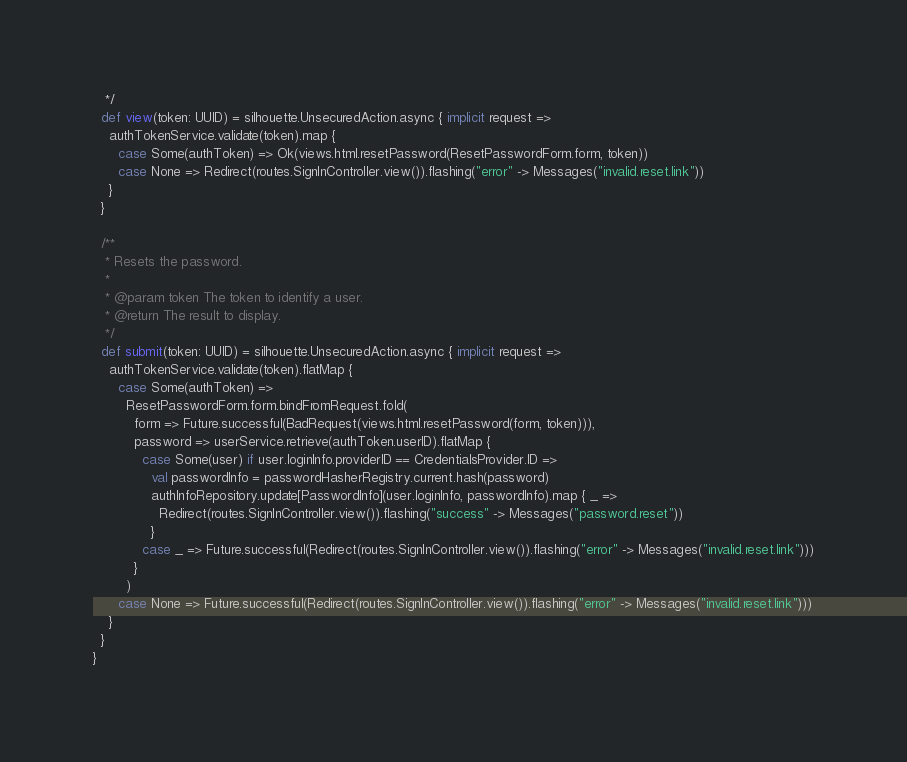Convert code to text. <code><loc_0><loc_0><loc_500><loc_500><_Scala_>   */
  def view(token: UUID) = silhouette.UnsecuredAction.async { implicit request =>
    authTokenService.validate(token).map {
      case Some(authToken) => Ok(views.html.resetPassword(ResetPasswordForm.form, token))
      case None => Redirect(routes.SignInController.view()).flashing("error" -> Messages("invalid.reset.link"))
    }
  }

  /**
   * Resets the password.
   *
   * @param token The token to identify a user.
   * @return The result to display.
   */
  def submit(token: UUID) = silhouette.UnsecuredAction.async { implicit request =>
    authTokenService.validate(token).flatMap {
      case Some(authToken) =>
        ResetPasswordForm.form.bindFromRequest.fold(
          form => Future.successful(BadRequest(views.html.resetPassword(form, token))),
          password => userService.retrieve(authToken.userID).flatMap {
            case Some(user) if user.loginInfo.providerID == CredentialsProvider.ID =>
              val passwordInfo = passwordHasherRegistry.current.hash(password)
              authInfoRepository.update[PasswordInfo](user.loginInfo, passwordInfo).map { _ =>
                Redirect(routes.SignInController.view()).flashing("success" -> Messages("password.reset"))
              }
            case _ => Future.successful(Redirect(routes.SignInController.view()).flashing("error" -> Messages("invalid.reset.link")))
          }
        )
      case None => Future.successful(Redirect(routes.SignInController.view()).flashing("error" -> Messages("invalid.reset.link")))
    }
  }
}
</code> 